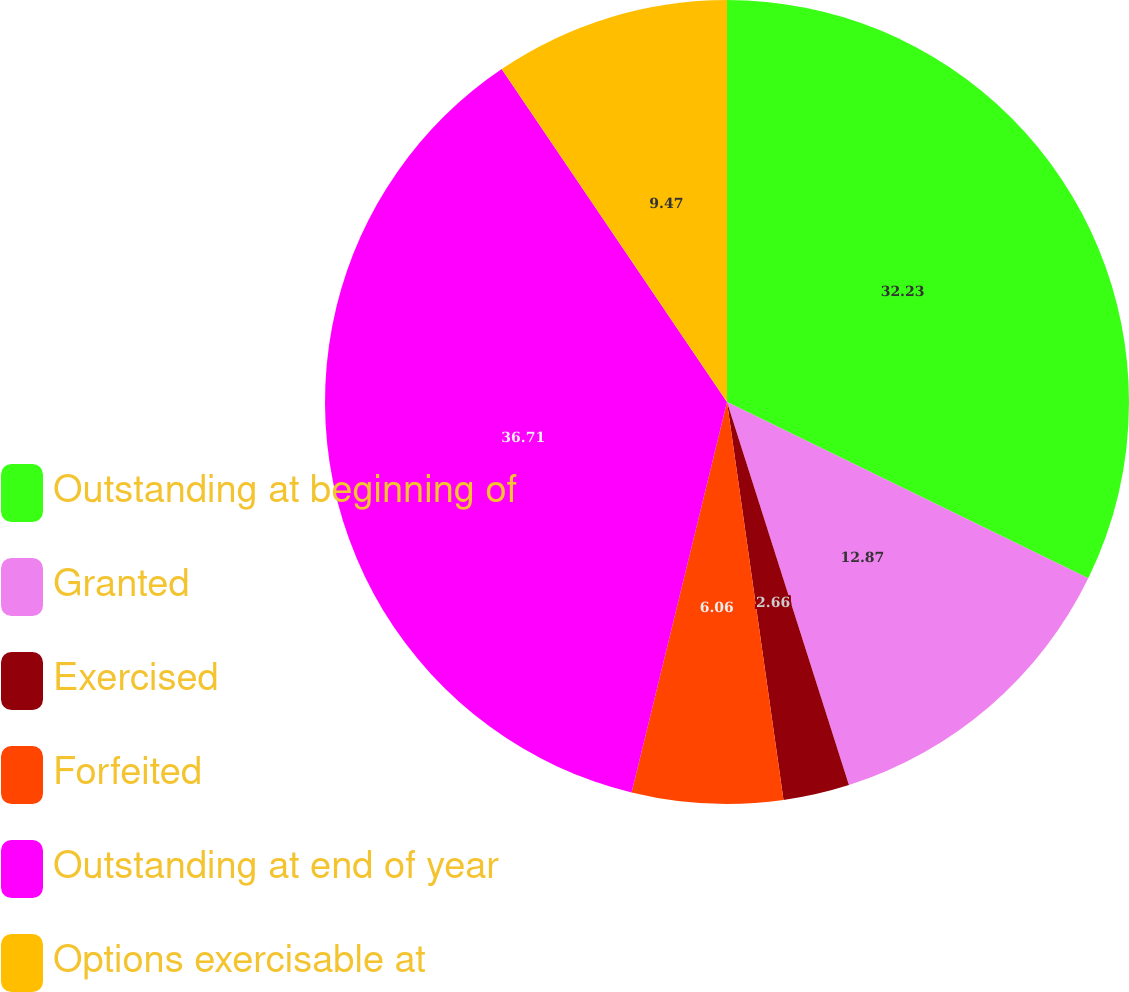Convert chart to OTSL. <chart><loc_0><loc_0><loc_500><loc_500><pie_chart><fcel>Outstanding at beginning of<fcel>Granted<fcel>Exercised<fcel>Forfeited<fcel>Outstanding at end of year<fcel>Options exercisable at<nl><fcel>32.23%<fcel>12.87%<fcel>2.66%<fcel>6.06%<fcel>36.72%<fcel>9.47%<nl></chart> 